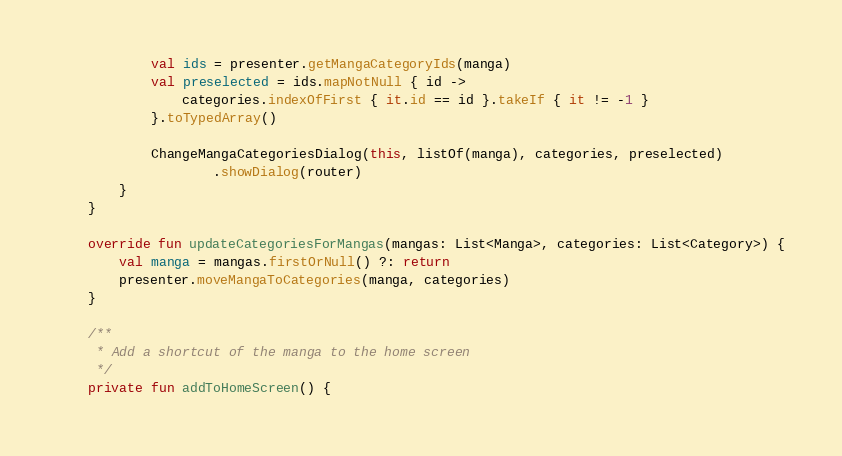Convert code to text. <code><loc_0><loc_0><loc_500><loc_500><_Kotlin_>            val ids = presenter.getMangaCategoryIds(manga)
            val preselected = ids.mapNotNull { id ->
                categories.indexOfFirst { it.id == id }.takeIf { it != -1 }
            }.toTypedArray()

            ChangeMangaCategoriesDialog(this, listOf(manga), categories, preselected)
                    .showDialog(router)
        }
    }

    override fun updateCategoriesForMangas(mangas: List<Manga>, categories: List<Category>) {
        val manga = mangas.firstOrNull() ?: return
        presenter.moveMangaToCategories(manga, categories)
    }

    /**
     * Add a shortcut of the manga to the home screen
     */
    private fun addToHomeScreen() {</code> 